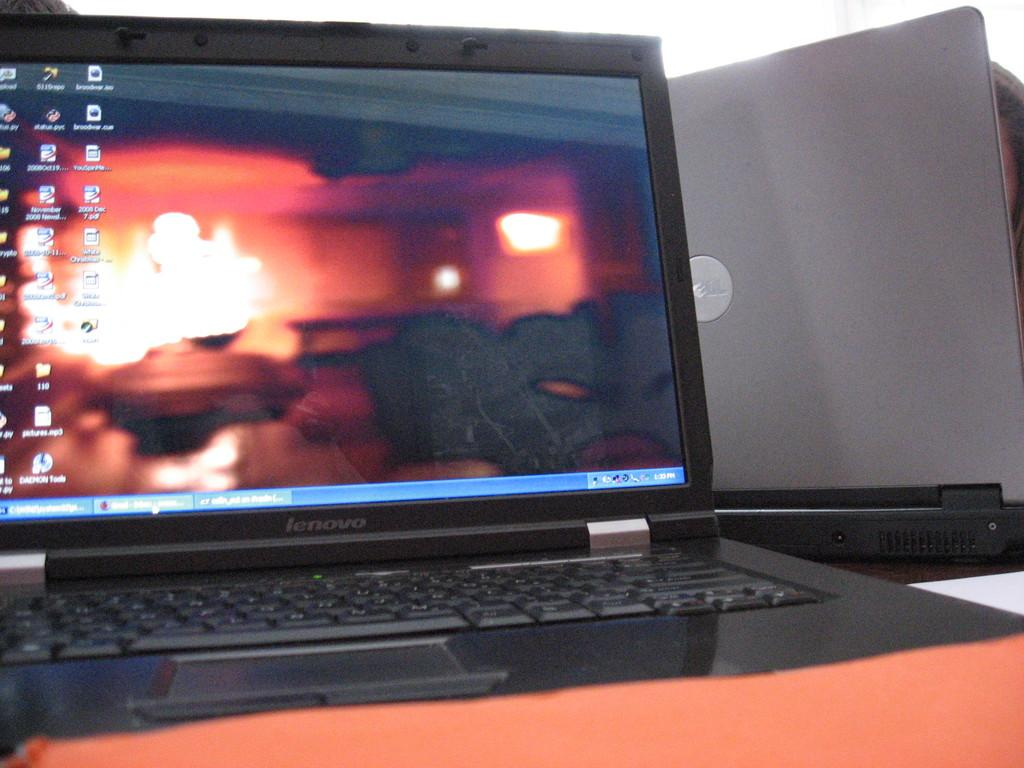<image>
Relay a brief, clear account of the picture shown. Computer monitor which says the word Lenovo on the bottom. 